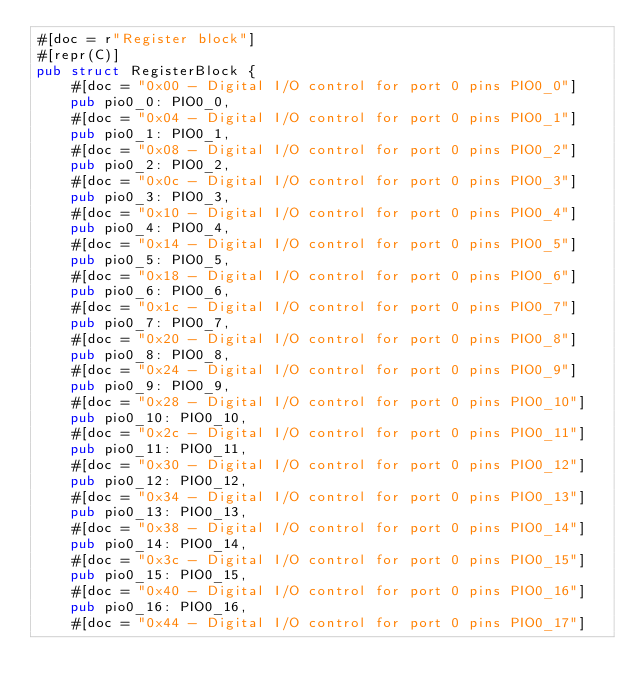<code> <loc_0><loc_0><loc_500><loc_500><_Rust_>#[doc = r"Register block"]
#[repr(C)]
pub struct RegisterBlock {
    #[doc = "0x00 - Digital I/O control for port 0 pins PIO0_0"]
    pub pio0_0: PIO0_0,
    #[doc = "0x04 - Digital I/O control for port 0 pins PIO0_1"]
    pub pio0_1: PIO0_1,
    #[doc = "0x08 - Digital I/O control for port 0 pins PIO0_2"]
    pub pio0_2: PIO0_2,
    #[doc = "0x0c - Digital I/O control for port 0 pins PIO0_3"]
    pub pio0_3: PIO0_3,
    #[doc = "0x10 - Digital I/O control for port 0 pins PIO0_4"]
    pub pio0_4: PIO0_4,
    #[doc = "0x14 - Digital I/O control for port 0 pins PIO0_5"]
    pub pio0_5: PIO0_5,
    #[doc = "0x18 - Digital I/O control for port 0 pins PIO0_6"]
    pub pio0_6: PIO0_6,
    #[doc = "0x1c - Digital I/O control for port 0 pins PIO0_7"]
    pub pio0_7: PIO0_7,
    #[doc = "0x20 - Digital I/O control for port 0 pins PIO0_8"]
    pub pio0_8: PIO0_8,
    #[doc = "0x24 - Digital I/O control for port 0 pins PIO0_9"]
    pub pio0_9: PIO0_9,
    #[doc = "0x28 - Digital I/O control for port 0 pins PIO0_10"]
    pub pio0_10: PIO0_10,
    #[doc = "0x2c - Digital I/O control for port 0 pins PIO0_11"]
    pub pio0_11: PIO0_11,
    #[doc = "0x30 - Digital I/O control for port 0 pins PIO0_12"]
    pub pio0_12: PIO0_12,
    #[doc = "0x34 - Digital I/O control for port 0 pins PIO0_13"]
    pub pio0_13: PIO0_13,
    #[doc = "0x38 - Digital I/O control for port 0 pins PIO0_14"]
    pub pio0_14: PIO0_14,
    #[doc = "0x3c - Digital I/O control for port 0 pins PIO0_15"]
    pub pio0_15: PIO0_15,
    #[doc = "0x40 - Digital I/O control for port 0 pins PIO0_16"]
    pub pio0_16: PIO0_16,
    #[doc = "0x44 - Digital I/O control for port 0 pins PIO0_17"]</code> 